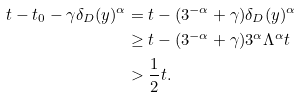<formula> <loc_0><loc_0><loc_500><loc_500>t - t _ { 0 } - \gamma \delta _ { D } ( y ) ^ { \alpha } & = t - ( 3 ^ { - \alpha } + \gamma ) \delta _ { D } ( y ) ^ { \alpha } \\ & \geq t - ( 3 ^ { - \alpha } + \gamma ) 3 ^ { \alpha } \Lambda ^ { \alpha } t \\ & > \frac { 1 } { 2 } t .</formula> 